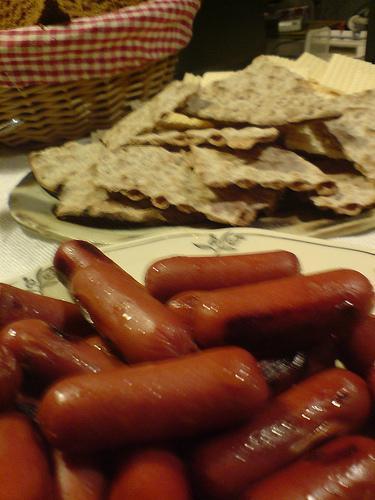How many baskets are in the photo?
Give a very brief answer. 1. 